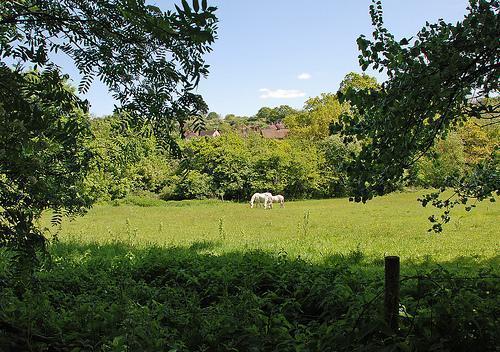How many horses is there?
Give a very brief answer. 2. 